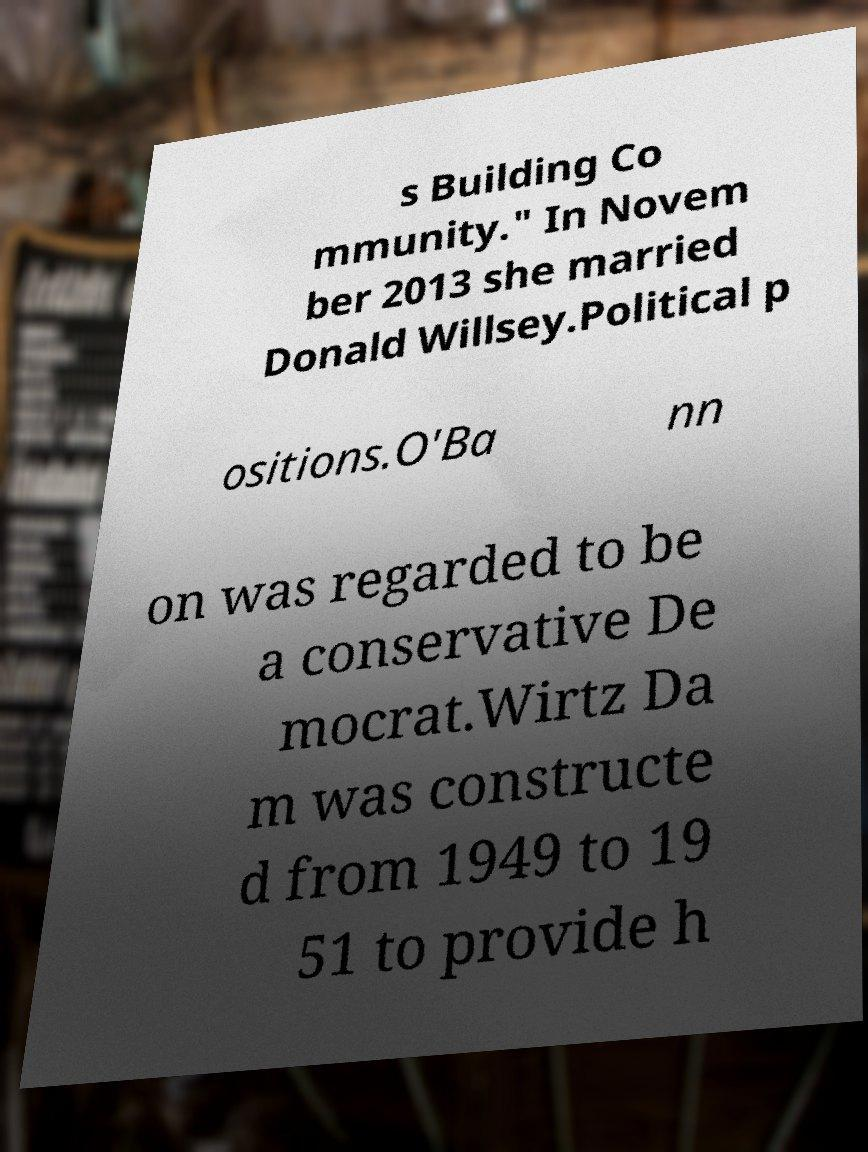Can you accurately transcribe the text from the provided image for me? s Building Co mmunity." In Novem ber 2013 she married Donald Willsey.Political p ositions.O'Ba nn on was regarded to be a conservative De mocrat.Wirtz Da m was constructe d from 1949 to 19 51 to provide h 